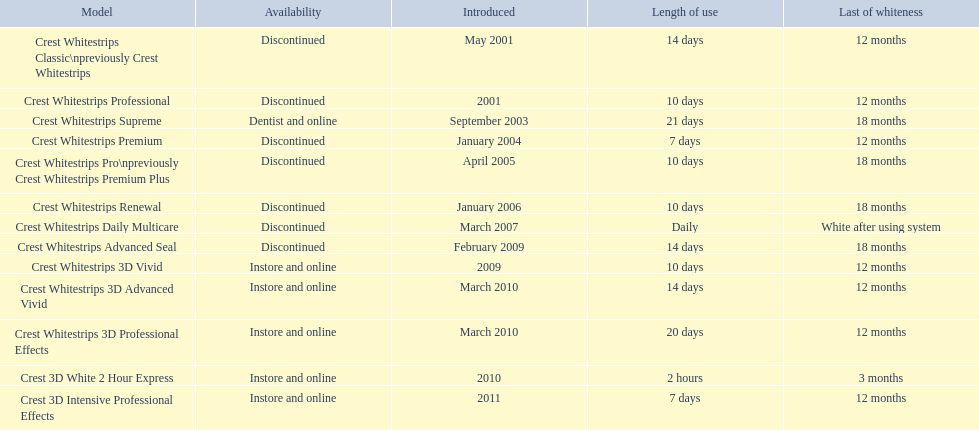When was crest whitestrips 3d advanced vivid introduced? March 2010. What other product was introduced in march 2010? Crest Whitestrips 3D Professional Effects. 